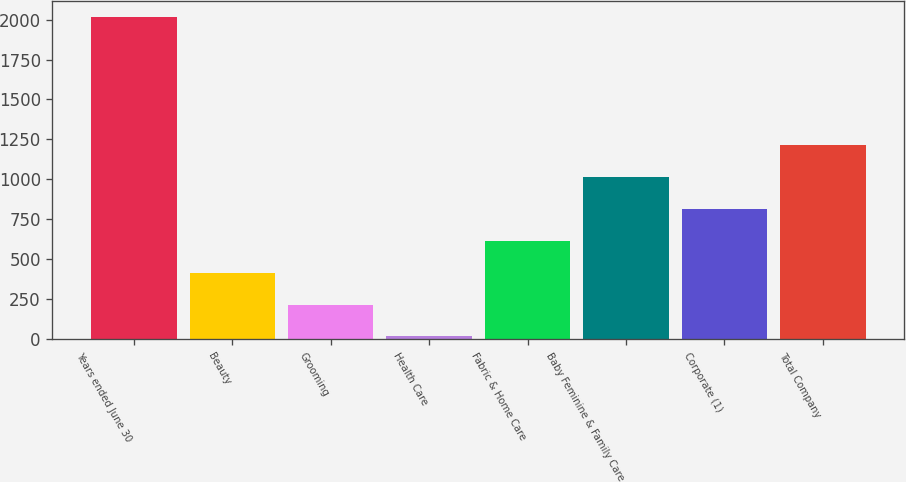<chart> <loc_0><loc_0><loc_500><loc_500><bar_chart><fcel>Years ended June 30<fcel>Beauty<fcel>Grooming<fcel>Health Care<fcel>Fabric & Home Care<fcel>Baby Feminine & Family Care<fcel>Corporate (1)<fcel>Total Company<nl><fcel>2017<fcel>415.4<fcel>215.2<fcel>15<fcel>615.6<fcel>1016<fcel>815.8<fcel>1216.2<nl></chart> 